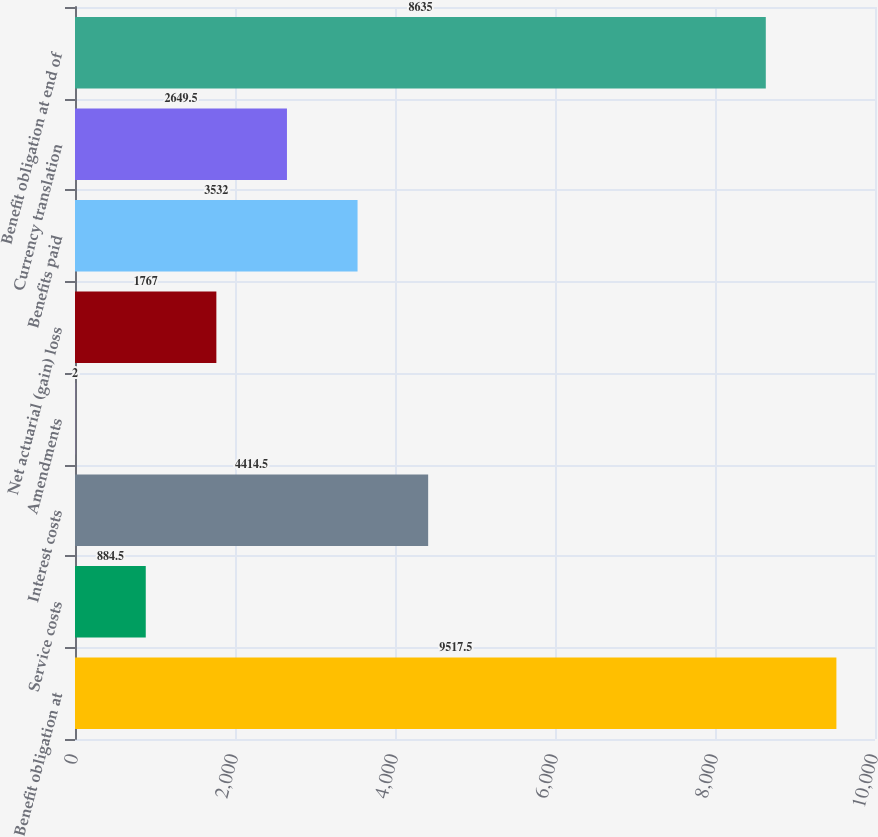<chart> <loc_0><loc_0><loc_500><loc_500><bar_chart><fcel>Benefit obligation at<fcel>Service costs<fcel>Interest costs<fcel>Amendments<fcel>Net actuarial (gain) loss<fcel>Benefits paid<fcel>Currency translation<fcel>Benefit obligation at end of<nl><fcel>9517.5<fcel>884.5<fcel>4414.5<fcel>2<fcel>1767<fcel>3532<fcel>2649.5<fcel>8635<nl></chart> 